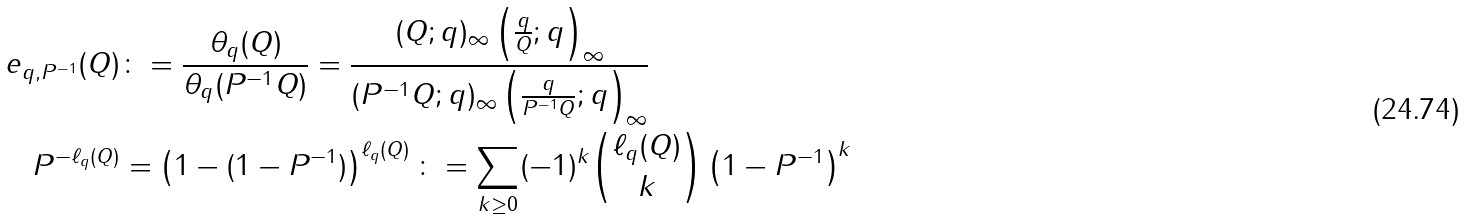<formula> <loc_0><loc_0><loc_500><loc_500>e _ { q , P ^ { - 1 } } ( Q ) & \colon = \frac { \theta _ { q } ( Q ) } { \theta _ { q } ( P ^ { - 1 } Q ) } = \frac { ( Q ; q ) _ { \infty } \left ( \frac { q } { Q } ; q \right ) _ { \infty } } { ( P ^ { - 1 } Q ; q ) _ { \infty } \left ( \frac { q } { P ^ { - 1 } Q } ; q \right ) _ { \infty } } \\ P ^ { - \ell _ { q } ( Q ) } & = \left ( 1 - ( 1 - P ^ { - 1 } ) \right ) ^ { \ell _ { q } ( Q ) } \colon = \sum _ { k \geq 0 } ( - 1 ) ^ { k } \binom { \ell _ { q } ( Q ) } { k } \left ( 1 - P ^ { - 1 } \right ) ^ { k }</formula> 